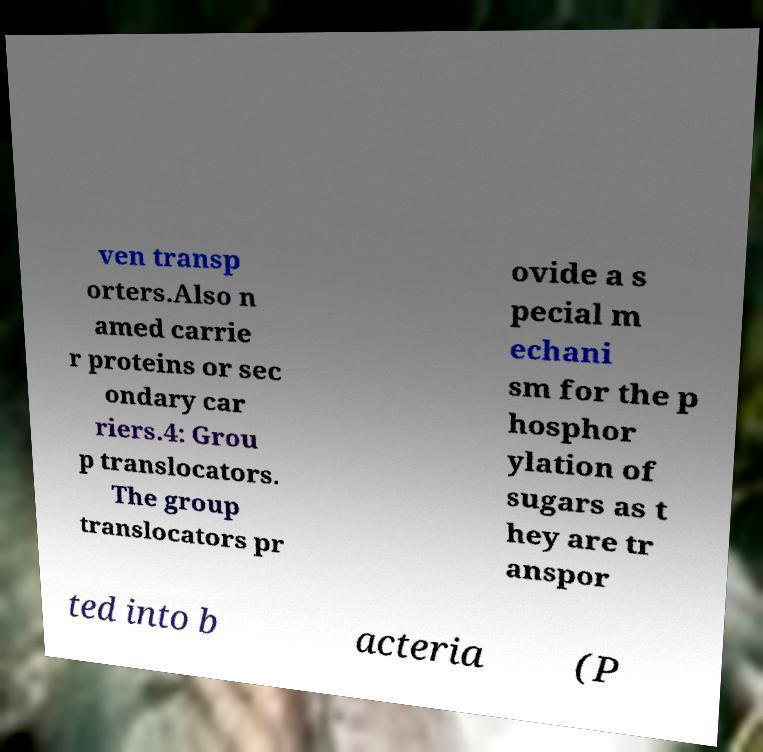There's text embedded in this image that I need extracted. Can you transcribe it verbatim? ven transp orters.Also n amed carrie r proteins or sec ondary car riers.4: Grou p translocators. The group translocators pr ovide a s pecial m echani sm for the p hosphor ylation of sugars as t hey are tr anspor ted into b acteria (P 